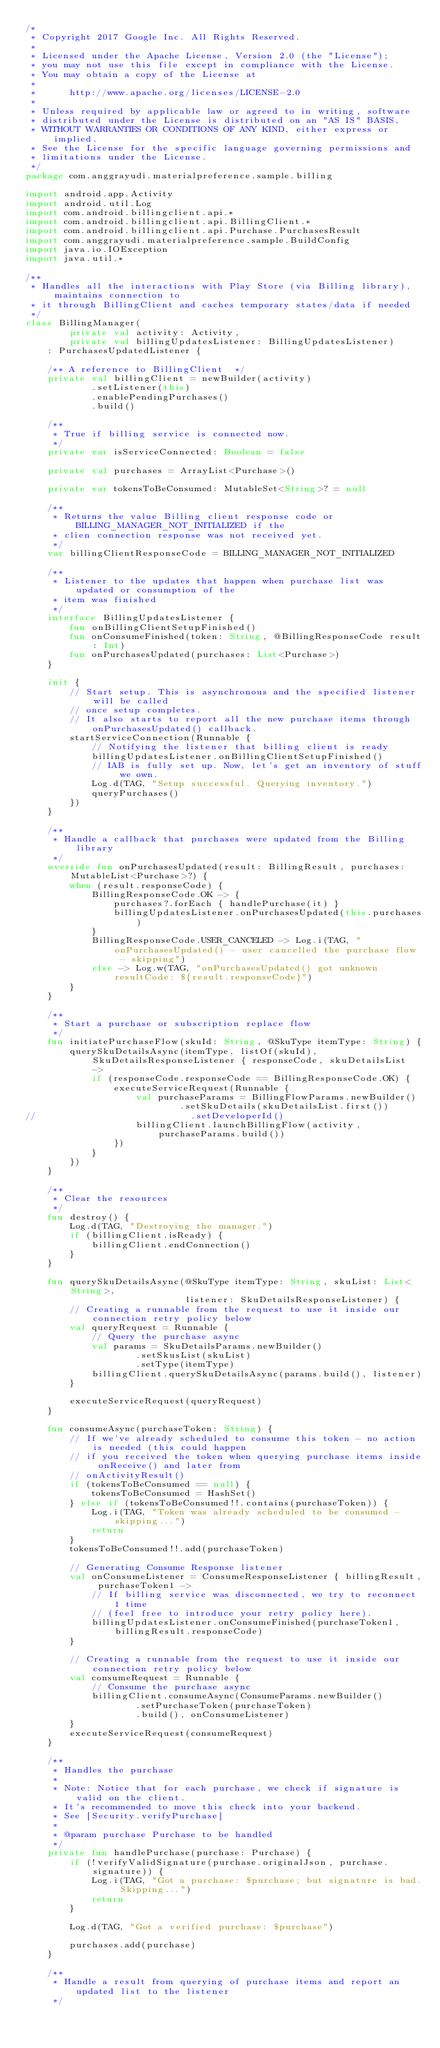Convert code to text. <code><loc_0><loc_0><loc_500><loc_500><_Kotlin_>/*
 * Copyright 2017 Google Inc. All Rights Reserved.
 *
 * Licensed under the Apache License, Version 2.0 (the "License");
 * you may not use this file except in compliance with the License.
 * You may obtain a copy of the License at
 *
 *      http://www.apache.org/licenses/LICENSE-2.0
 *
 * Unless required by applicable law or agreed to in writing, software
 * distributed under the License is distributed on an "AS IS" BASIS,
 * WITHOUT WARRANTIES OR CONDITIONS OF ANY KIND, either express or implied.
 * See the License for the specific language governing permissions and
 * limitations under the License.
 */
package com.anggrayudi.materialpreference.sample.billing

import android.app.Activity
import android.util.Log
import com.android.billingclient.api.*
import com.android.billingclient.api.BillingClient.*
import com.android.billingclient.api.Purchase.PurchasesResult
import com.anggrayudi.materialpreference.sample.BuildConfig
import java.io.IOException
import java.util.*

/**
 * Handles all the interactions with Play Store (via Billing library), maintains connection to
 * it through BillingClient and caches temporary states/data if needed
 */
class BillingManager(
        private val activity: Activity,
        private val billingUpdatesListener: BillingUpdatesListener)
    : PurchasesUpdatedListener {

    /** A reference to BillingClient  */
    private val billingClient = newBuilder(activity)
            .setListener(this)
            .enablePendingPurchases()
            .build()

    /**
     * True if billing service is connected now.
     */
    private var isServiceConnected: Boolean = false

    private val purchases = ArrayList<Purchase>()

    private var tokensToBeConsumed: MutableSet<String>? = null

    /**
     * Returns the value Billing client response code or BILLING_MANAGER_NOT_INITIALIZED if the
     * clien connection response was not received yet.
     */
    var billingClientResponseCode = BILLING_MANAGER_NOT_INITIALIZED

    /**
     * Listener to the updates that happen when purchase list was updated or consumption of the
     * item was finished
     */
    interface BillingUpdatesListener {
        fun onBillingClientSetupFinished()
        fun onConsumeFinished(token: String, @BillingResponseCode result: Int)
        fun onPurchasesUpdated(purchases: List<Purchase>)
    }

    init {
        // Start setup. This is asynchronous and the specified listener will be called
        // once setup completes.
        // It also starts to report all the new purchase items through onPurchasesUpdated() callback.
        startServiceConnection(Runnable {
            // Notifying the listener that billing client is ready
            billingUpdatesListener.onBillingClientSetupFinished()
            // IAB is fully set up. Now, let's get an inventory of stuff we own.
            Log.d(TAG, "Setup successful. Querying inventory.")
            queryPurchases()
        })
    }

    /**
     * Handle a callback that purchases were updated from the Billing library
     */
    override fun onPurchasesUpdated(result: BillingResult, purchases: MutableList<Purchase>?) {
        when (result.responseCode) {
            BillingResponseCode.OK -> {
                purchases?.forEach { handlePurchase(it) }
                billingUpdatesListener.onPurchasesUpdated(this.purchases)
            }
            BillingResponseCode.USER_CANCELED -> Log.i(TAG, "onPurchasesUpdated() - user cancelled the purchase flow - skipping")
            else -> Log.w(TAG, "onPurchasesUpdated() got unknown resultCode: ${result.responseCode}")
        }
    }

    /**
     * Start a purchase or subscription replace flow
     */
    fun initiatePurchaseFlow(skuId: String, @SkuType itemType: String) {
        querySkuDetailsAsync(itemType, listOf(skuId), SkuDetailsResponseListener { responseCode, skuDetailsList ->
            if (responseCode.responseCode == BillingResponseCode.OK) {
                executeServiceRequest(Runnable {
                    val purchaseParams = BillingFlowParams.newBuilder()
                            .setSkuDetails(skuDetailsList.first())
//                            .setDeveloperId()
                    billingClient.launchBillingFlow(activity, purchaseParams.build())
                })
            }
        })
    }

    /**
     * Clear the resources
     */
    fun destroy() {
        Log.d(TAG, "Destroying the manager.")
        if (billingClient.isReady) {
            billingClient.endConnection()
        }
    }

    fun querySkuDetailsAsync(@SkuType itemType: String, skuList: List<String>,
                             listener: SkuDetailsResponseListener) {
        // Creating a runnable from the request to use it inside our connection retry policy below
        val queryRequest = Runnable {
            // Query the purchase async
            val params = SkuDetailsParams.newBuilder()
                    .setSkusList(skuList)
                    .setType(itemType)
            billingClient.querySkuDetailsAsync(params.build(), listener)
        }

        executeServiceRequest(queryRequest)
    }

    fun consumeAsync(purchaseToken: String) {
        // If we've already scheduled to consume this token - no action is needed (this could happen
        // if you received the token when querying purchase items inside onReceive() and later from
        // onActivityResult()
        if (tokensToBeConsumed == null) {
            tokensToBeConsumed = HashSet()
        } else if (tokensToBeConsumed!!.contains(purchaseToken)) {
            Log.i(TAG, "Token was already scheduled to be consumed - skipping...")
            return
        }
        tokensToBeConsumed!!.add(purchaseToken)

        // Generating Consume Response listener
        val onConsumeListener = ConsumeResponseListener { billingResult, purchaseToken1 ->
            // If billing service was disconnected, we try to reconnect 1 time
            // (feel free to introduce your retry policy here).
            billingUpdatesListener.onConsumeFinished(purchaseToken1, billingResult.responseCode)
        }

        // Creating a runnable from the request to use it inside our connection retry policy below
        val consumeRequest = Runnable {
            // Consume the purchase async
            billingClient.consumeAsync(ConsumeParams.newBuilder()
                    .setPurchaseToken(purchaseToken)
                    .build(), onConsumeListener)
        }
        executeServiceRequest(consumeRequest)
    }

    /**
     * Handles the purchase
     *
     * Note: Notice that for each purchase, we check if signature is valid on the client.
     * It's recommended to move this check into your backend.
     * See [Security.verifyPurchase]
     *
     * @param purchase Purchase to be handled
     */
    private fun handlePurchase(purchase: Purchase) {
        if (!verifyValidSignature(purchase.originalJson, purchase.signature)) {
            Log.i(TAG, "Got a purchase: $purchase; but signature is bad. Skipping...")
            return
        }

        Log.d(TAG, "Got a verified purchase: $purchase")

        purchases.add(purchase)
    }

    /**
     * Handle a result from querying of purchase items and report an updated list to the listener
     */</code> 